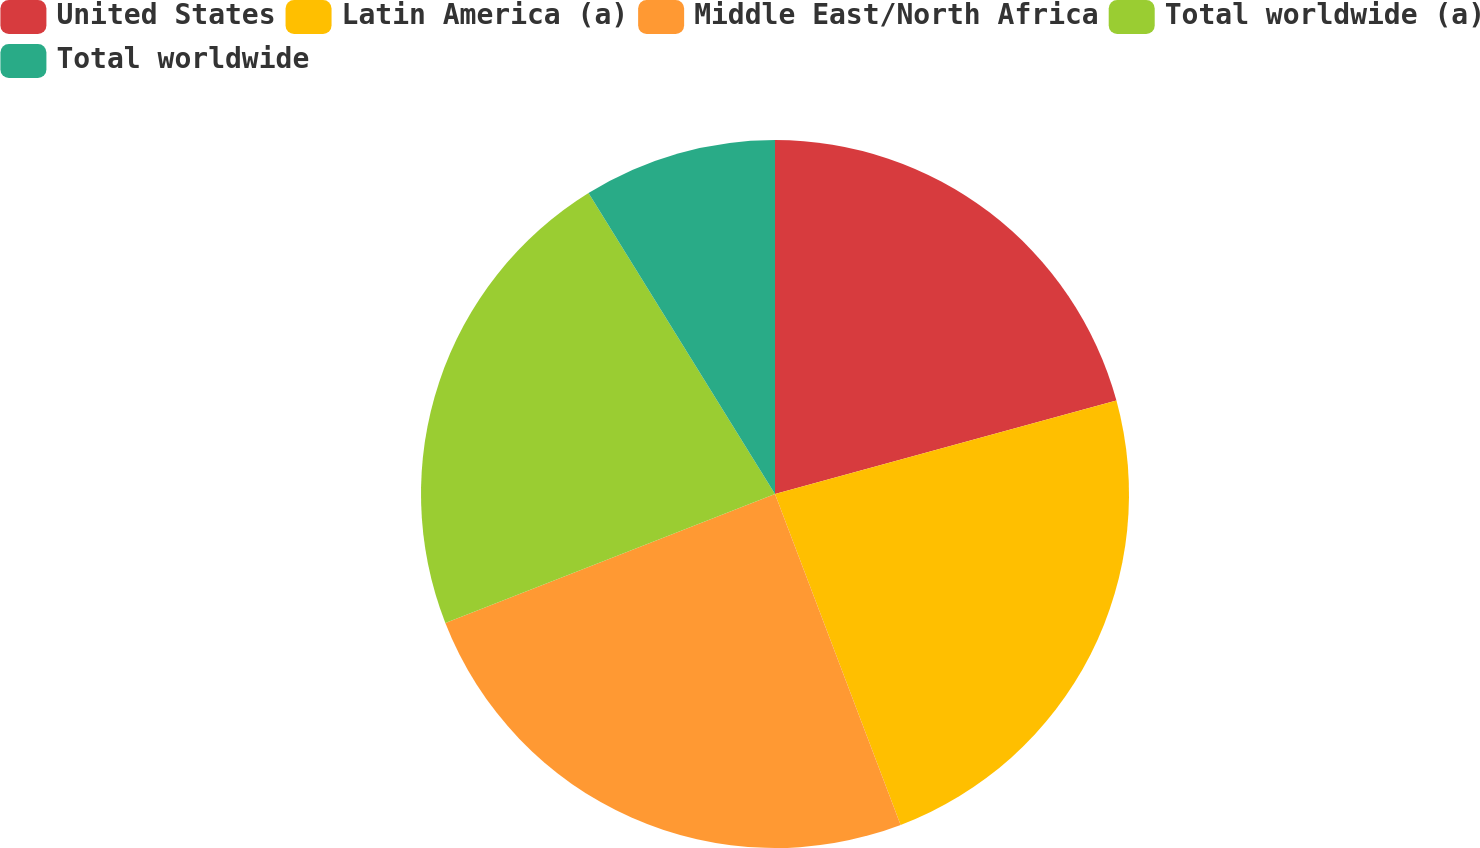Convert chart to OTSL. <chart><loc_0><loc_0><loc_500><loc_500><pie_chart><fcel>United States<fcel>Latin America (a)<fcel>Middle East/North Africa<fcel>Total worldwide (a)<fcel>Total worldwide<nl><fcel>20.75%<fcel>23.48%<fcel>24.84%<fcel>22.11%<fcel>8.83%<nl></chart> 